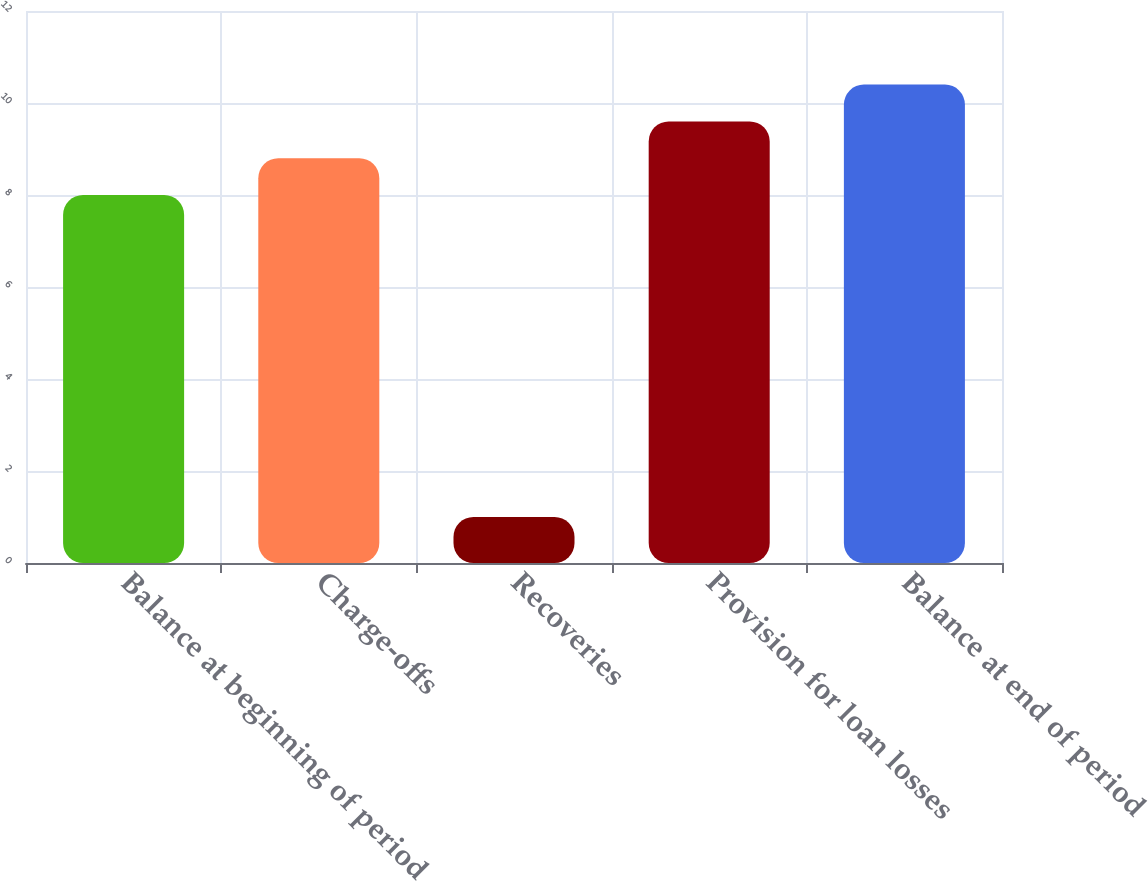Convert chart. <chart><loc_0><loc_0><loc_500><loc_500><bar_chart><fcel>Balance at beginning of period<fcel>Charge-offs<fcel>Recoveries<fcel>Provision for loan losses<fcel>Balance at end of period<nl><fcel>8<fcel>8.8<fcel>1<fcel>9.6<fcel>10.4<nl></chart> 